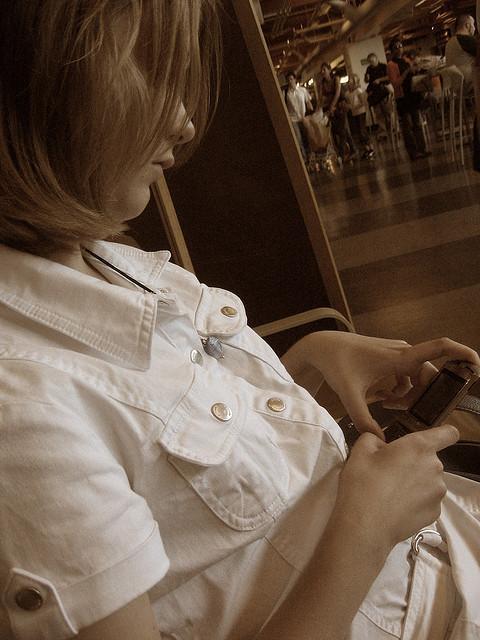What are the people lining up for?
Select the accurate response from the four choices given to answer the question.
Options: Boarding bus, boarding plane, buying tickets, buying food. Buying food. 